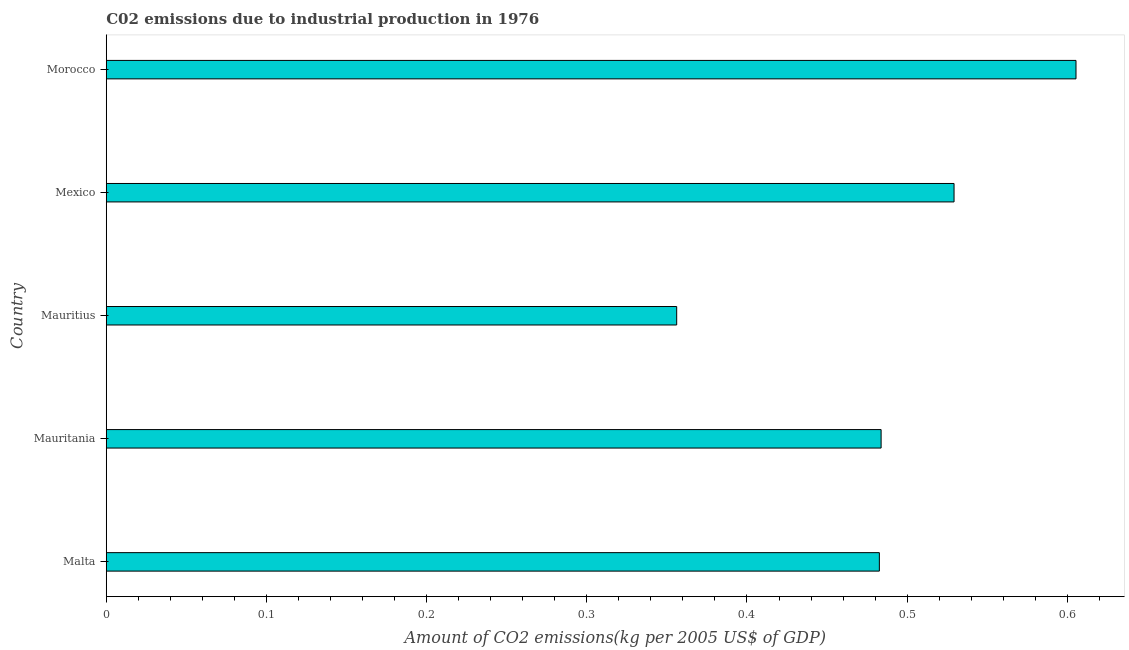Does the graph contain grids?
Provide a succinct answer. No. What is the title of the graph?
Your answer should be compact. C02 emissions due to industrial production in 1976. What is the label or title of the X-axis?
Keep it short and to the point. Amount of CO2 emissions(kg per 2005 US$ of GDP). What is the label or title of the Y-axis?
Your answer should be compact. Country. What is the amount of co2 emissions in Mauritania?
Offer a very short reply. 0.48. Across all countries, what is the maximum amount of co2 emissions?
Your answer should be very brief. 0.61. Across all countries, what is the minimum amount of co2 emissions?
Your answer should be very brief. 0.36. In which country was the amount of co2 emissions maximum?
Offer a terse response. Morocco. In which country was the amount of co2 emissions minimum?
Ensure brevity in your answer.  Mauritius. What is the sum of the amount of co2 emissions?
Provide a succinct answer. 2.46. What is the difference between the amount of co2 emissions in Malta and Mauritania?
Your response must be concise. -0. What is the average amount of co2 emissions per country?
Your answer should be compact. 0.49. What is the median amount of co2 emissions?
Offer a terse response. 0.48. In how many countries, is the amount of co2 emissions greater than 0.02 kg per 2005 US$ of GDP?
Keep it short and to the point. 5. What is the ratio of the amount of co2 emissions in Malta to that in Morocco?
Give a very brief answer. 0.8. Is the amount of co2 emissions in Mauritania less than that in Mexico?
Provide a succinct answer. Yes. What is the difference between the highest and the second highest amount of co2 emissions?
Provide a succinct answer. 0.08. What is the difference between the highest and the lowest amount of co2 emissions?
Keep it short and to the point. 0.25. How many bars are there?
Ensure brevity in your answer.  5. Are the values on the major ticks of X-axis written in scientific E-notation?
Keep it short and to the point. No. What is the Amount of CO2 emissions(kg per 2005 US$ of GDP) of Malta?
Provide a short and direct response. 0.48. What is the Amount of CO2 emissions(kg per 2005 US$ of GDP) of Mauritania?
Ensure brevity in your answer.  0.48. What is the Amount of CO2 emissions(kg per 2005 US$ of GDP) of Mauritius?
Give a very brief answer. 0.36. What is the Amount of CO2 emissions(kg per 2005 US$ of GDP) of Mexico?
Keep it short and to the point. 0.53. What is the Amount of CO2 emissions(kg per 2005 US$ of GDP) in Morocco?
Offer a terse response. 0.61. What is the difference between the Amount of CO2 emissions(kg per 2005 US$ of GDP) in Malta and Mauritania?
Give a very brief answer. -0. What is the difference between the Amount of CO2 emissions(kg per 2005 US$ of GDP) in Malta and Mauritius?
Provide a succinct answer. 0.13. What is the difference between the Amount of CO2 emissions(kg per 2005 US$ of GDP) in Malta and Mexico?
Ensure brevity in your answer.  -0.05. What is the difference between the Amount of CO2 emissions(kg per 2005 US$ of GDP) in Malta and Morocco?
Provide a succinct answer. -0.12. What is the difference between the Amount of CO2 emissions(kg per 2005 US$ of GDP) in Mauritania and Mauritius?
Offer a very short reply. 0.13. What is the difference between the Amount of CO2 emissions(kg per 2005 US$ of GDP) in Mauritania and Mexico?
Provide a succinct answer. -0.05. What is the difference between the Amount of CO2 emissions(kg per 2005 US$ of GDP) in Mauritania and Morocco?
Your answer should be compact. -0.12. What is the difference between the Amount of CO2 emissions(kg per 2005 US$ of GDP) in Mauritius and Mexico?
Offer a terse response. -0.17. What is the difference between the Amount of CO2 emissions(kg per 2005 US$ of GDP) in Mauritius and Morocco?
Keep it short and to the point. -0.25. What is the difference between the Amount of CO2 emissions(kg per 2005 US$ of GDP) in Mexico and Morocco?
Offer a very short reply. -0.08. What is the ratio of the Amount of CO2 emissions(kg per 2005 US$ of GDP) in Malta to that in Mauritius?
Provide a succinct answer. 1.35. What is the ratio of the Amount of CO2 emissions(kg per 2005 US$ of GDP) in Malta to that in Mexico?
Give a very brief answer. 0.91. What is the ratio of the Amount of CO2 emissions(kg per 2005 US$ of GDP) in Malta to that in Morocco?
Provide a succinct answer. 0.8. What is the ratio of the Amount of CO2 emissions(kg per 2005 US$ of GDP) in Mauritania to that in Mauritius?
Keep it short and to the point. 1.36. What is the ratio of the Amount of CO2 emissions(kg per 2005 US$ of GDP) in Mauritania to that in Mexico?
Provide a succinct answer. 0.91. What is the ratio of the Amount of CO2 emissions(kg per 2005 US$ of GDP) in Mauritania to that in Morocco?
Keep it short and to the point. 0.8. What is the ratio of the Amount of CO2 emissions(kg per 2005 US$ of GDP) in Mauritius to that in Mexico?
Your answer should be very brief. 0.67. What is the ratio of the Amount of CO2 emissions(kg per 2005 US$ of GDP) in Mauritius to that in Morocco?
Your answer should be compact. 0.59. What is the ratio of the Amount of CO2 emissions(kg per 2005 US$ of GDP) in Mexico to that in Morocco?
Your answer should be compact. 0.87. 